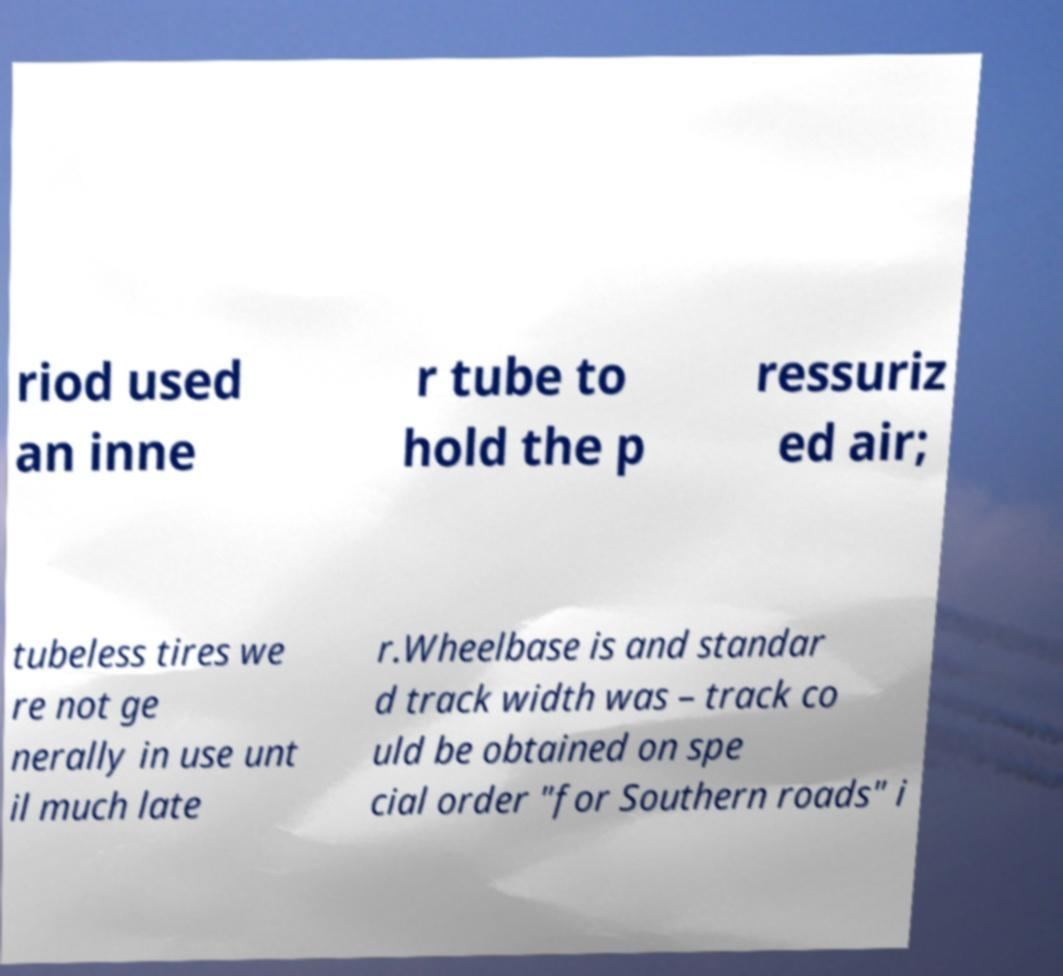Can you accurately transcribe the text from the provided image for me? riod used an inne r tube to hold the p ressuriz ed air; tubeless tires we re not ge nerally in use unt il much late r.Wheelbase is and standar d track width was – track co uld be obtained on spe cial order "for Southern roads" i 